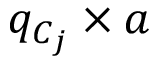Convert formula to latex. <formula><loc_0><loc_0><loc_500><loc_500>q _ { C _ { j } } \times a</formula> 